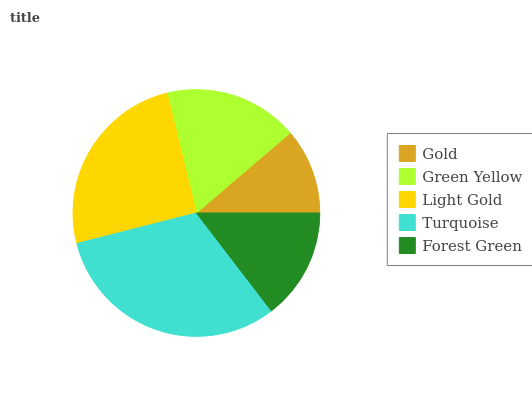Is Gold the minimum?
Answer yes or no. Yes. Is Turquoise the maximum?
Answer yes or no. Yes. Is Green Yellow the minimum?
Answer yes or no. No. Is Green Yellow the maximum?
Answer yes or no. No. Is Green Yellow greater than Gold?
Answer yes or no. Yes. Is Gold less than Green Yellow?
Answer yes or no. Yes. Is Gold greater than Green Yellow?
Answer yes or no. No. Is Green Yellow less than Gold?
Answer yes or no. No. Is Green Yellow the high median?
Answer yes or no. Yes. Is Green Yellow the low median?
Answer yes or no. Yes. Is Turquoise the high median?
Answer yes or no. No. Is Light Gold the low median?
Answer yes or no. No. 